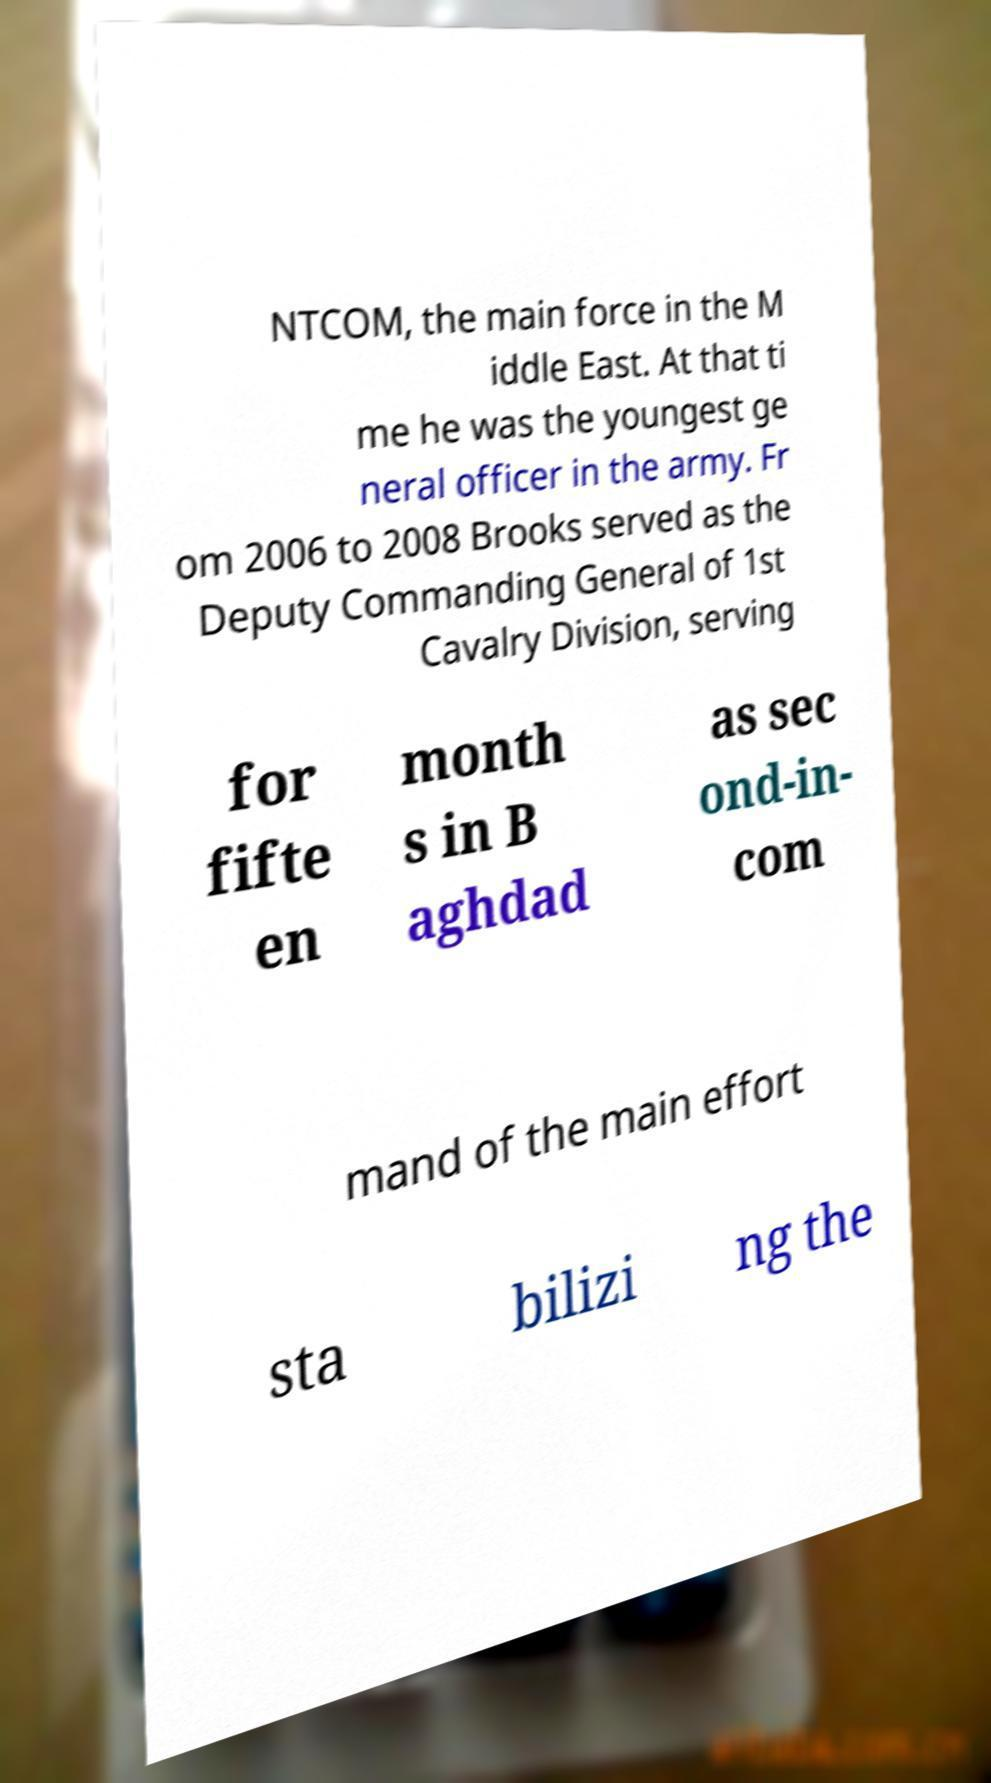What messages or text are displayed in this image? I need them in a readable, typed format. NTCOM, the main force in the M iddle East. At that ti me he was the youngest ge neral officer in the army. Fr om 2006 to 2008 Brooks served as the Deputy Commanding General of 1st Cavalry Division, serving for fifte en month s in B aghdad as sec ond-in- com mand of the main effort sta bilizi ng the 